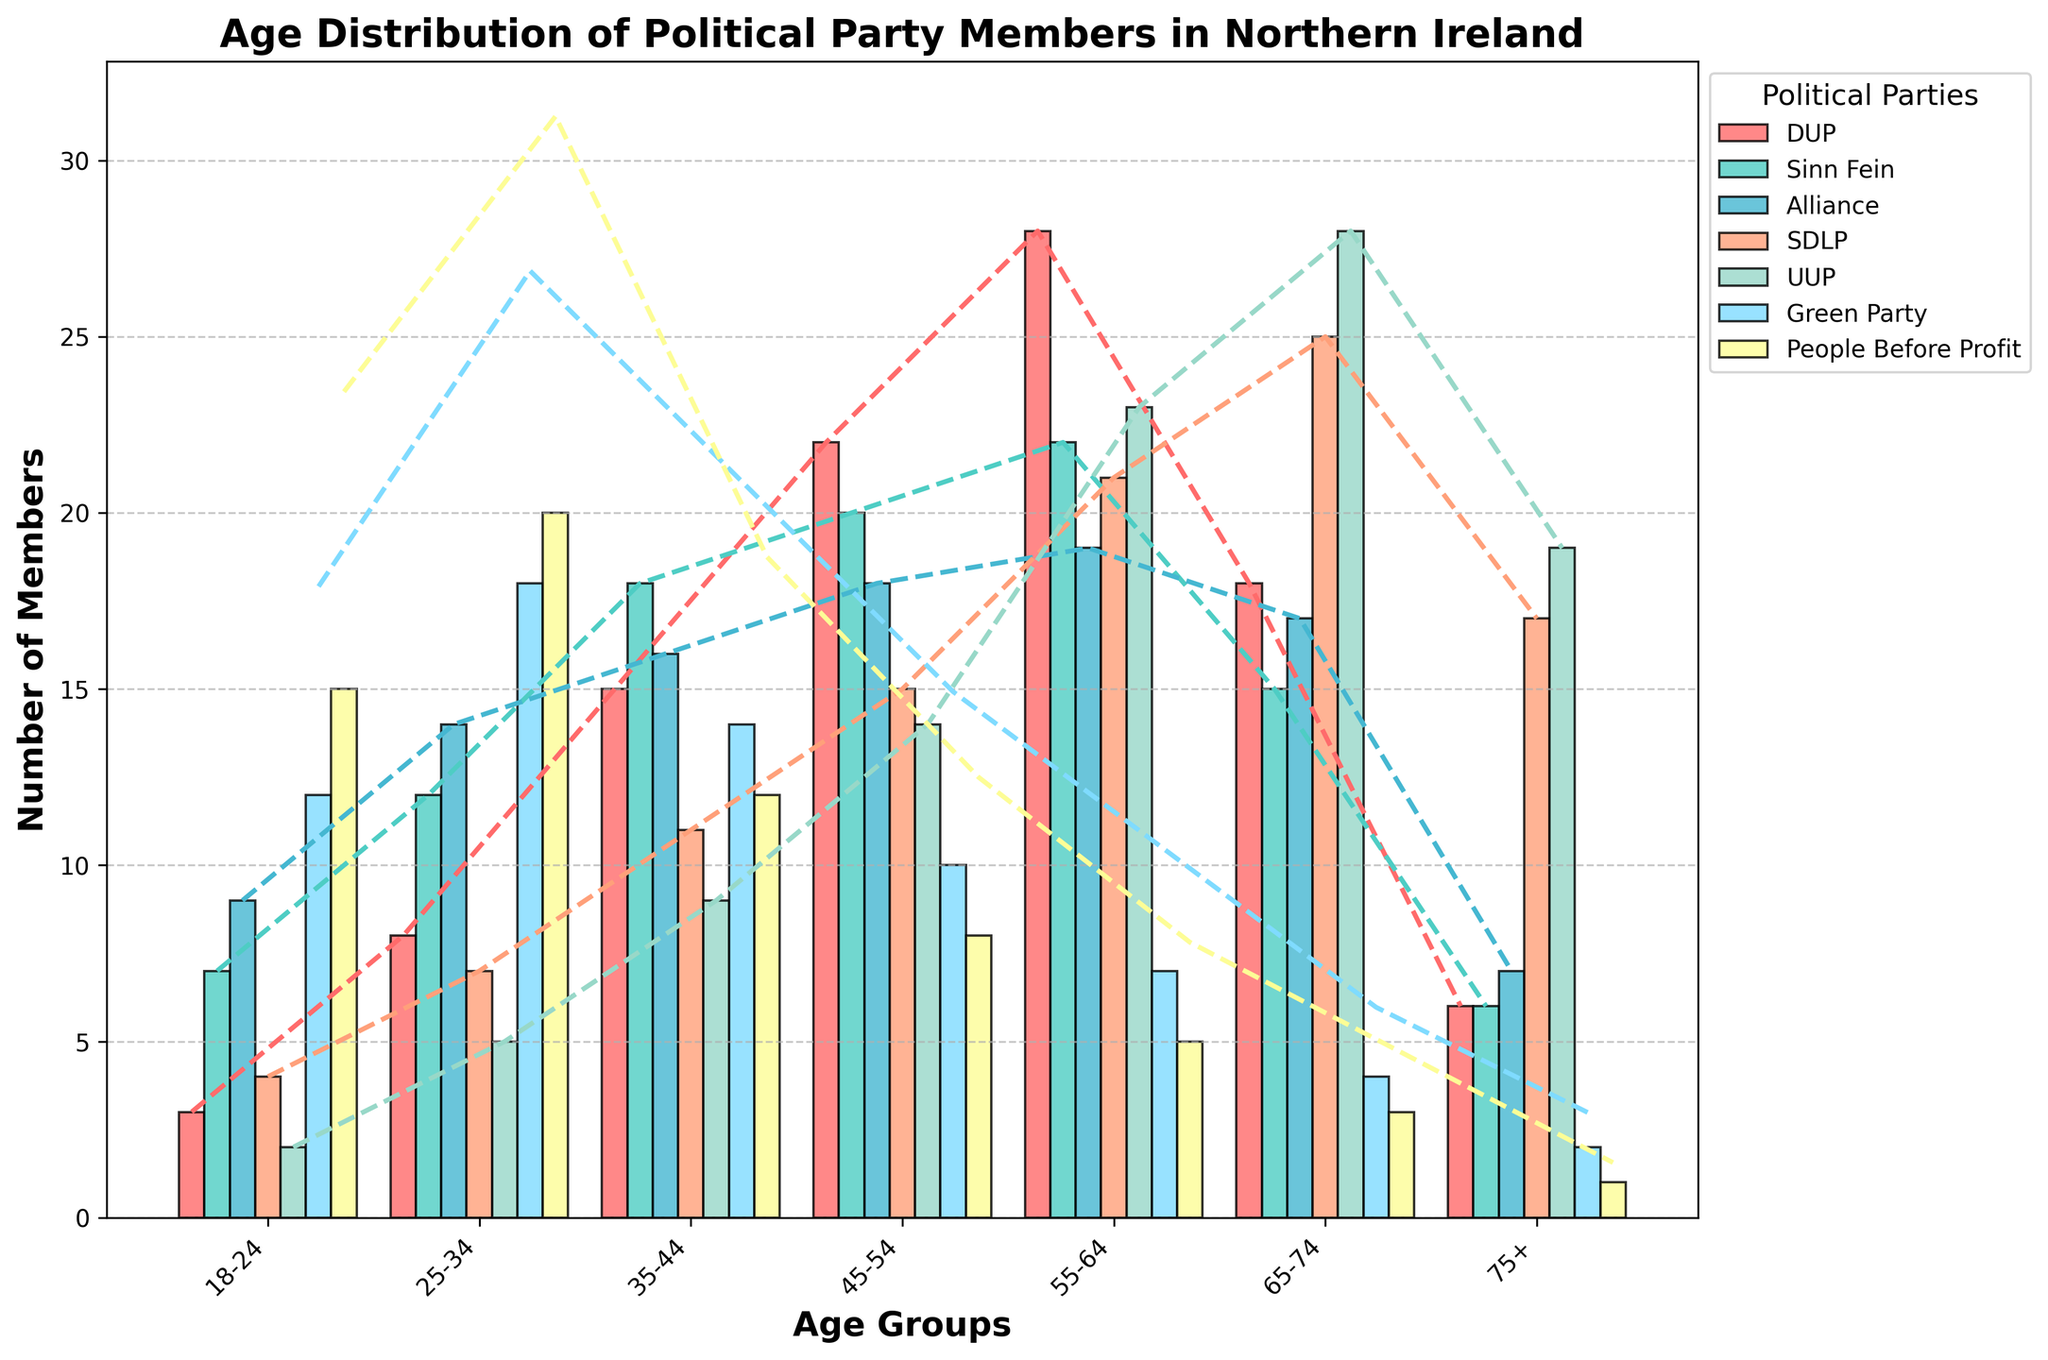What is the title of the figure? The title of the figure is typically found at the top of the chart and provides a summary of the data presented.
Answer: Age Distribution of Political Party Members in Northern Ireland Which age group has the highest number of DUP members? To answer this, find the tallest bar for the DUP members, which is indicated by its specific color in the chart.
Answer: 55-64 How many age groups are represented in the figure? Count the number of distinct age groups on the x-axis labeled under the bars.
Answer: 7 Which party has the most members in the 18-24 age group? Look at the height of each bar corresponding to the 18-24 age group for each party.
Answer: People Before Profit What is the total number of Sinn Fein members across all age groups? Sum the heights of all Sinn Fein bars across all age groups.
Answer: 100 Which two parties have the closest number of members in the 45-54 age group? Compare the heights of the bars for each party in the 45-54 age group and identify the two with the smallest difference.
Answer: Sinn Fein and Alliance Which age group has the lowest overall number of members across all parties? Sum the heights of the bars for each age group and find the age group with the smallest total.
Answer: 18-24 How does the KDE line for the Green Party compare to the KDE line for the UUP? Examine the dashed KDE lines for both parties and compare their shapes and peaks.
Answer: The Green Party's KDE line has a peak shifted more towards the younger age groups compared to the UUP Which party shows a consistent decrease in members as age increases? Identify the party whose bars generally decrease in height as the age groups progress from younger to older.
Answer: People Before Profit What is the trend of Alliance party members from the 25-34 to 45-54 age group? Observe the heights of the bars for the Alliance party in the specified age groups and determine the trend.
Answer: Increasing 